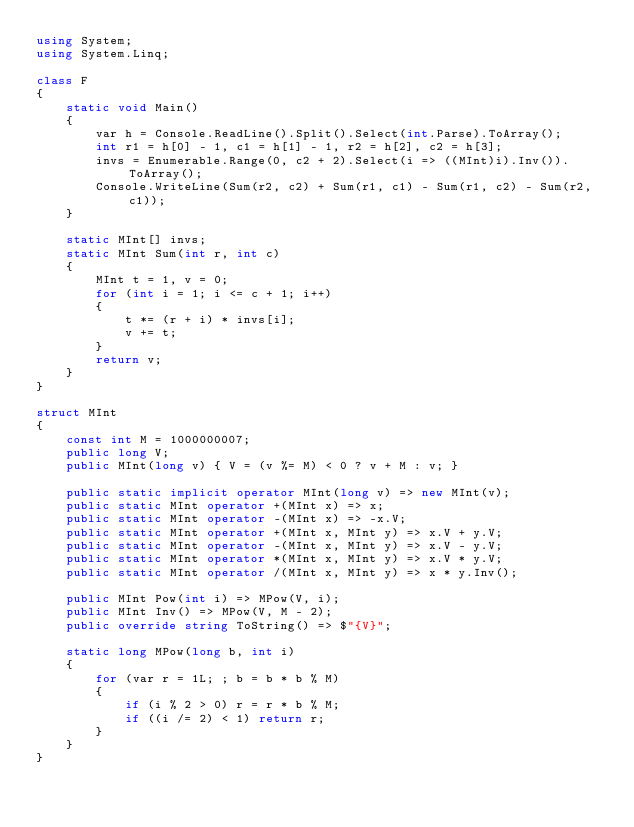Convert code to text. <code><loc_0><loc_0><loc_500><loc_500><_C#_>using System;
using System.Linq;

class F
{
	static void Main()
	{
		var h = Console.ReadLine().Split().Select(int.Parse).ToArray();
		int r1 = h[0] - 1, c1 = h[1] - 1, r2 = h[2], c2 = h[3];
		invs = Enumerable.Range(0, c2 + 2).Select(i => ((MInt)i).Inv()).ToArray();
		Console.WriteLine(Sum(r2, c2) + Sum(r1, c1) - Sum(r1, c2) - Sum(r2, c1));
	}

	static MInt[] invs;
	static MInt Sum(int r, int c)
	{
		MInt t = 1, v = 0;
		for (int i = 1; i <= c + 1; i++)
		{
			t *= (r + i) * invs[i];
			v += t;
		}
		return v;
	}
}

struct MInt
{
	const int M = 1000000007;
	public long V;
	public MInt(long v) { V = (v %= M) < 0 ? v + M : v; }

	public static implicit operator MInt(long v) => new MInt(v);
	public static MInt operator +(MInt x) => x;
	public static MInt operator -(MInt x) => -x.V;
	public static MInt operator +(MInt x, MInt y) => x.V + y.V;
	public static MInt operator -(MInt x, MInt y) => x.V - y.V;
	public static MInt operator *(MInt x, MInt y) => x.V * y.V;
	public static MInt operator /(MInt x, MInt y) => x * y.Inv();

	public MInt Pow(int i) => MPow(V, i);
	public MInt Inv() => MPow(V, M - 2);
	public override string ToString() => $"{V}";

	static long MPow(long b, int i)
	{
		for (var r = 1L; ; b = b * b % M)
		{
			if (i % 2 > 0) r = r * b % M;
			if ((i /= 2) < 1) return r;
		}
	}
}
</code> 